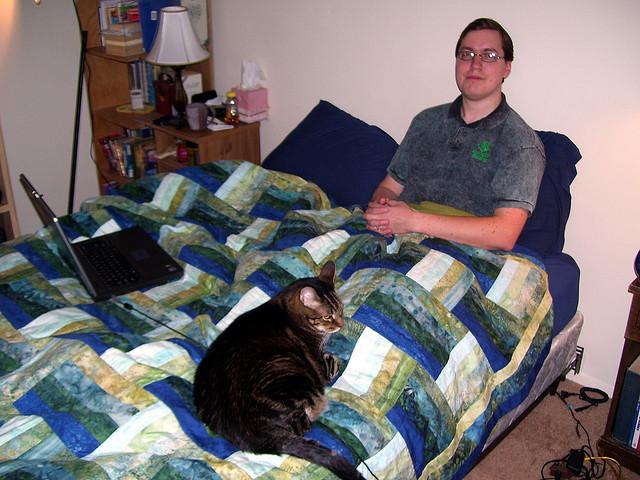Why is the cat on the bed?
Give a very brief answer. Tired. Is this a log cabin style quilt?
Be succinct. Yes. What size bed is this?
Concise answer only. Full. 